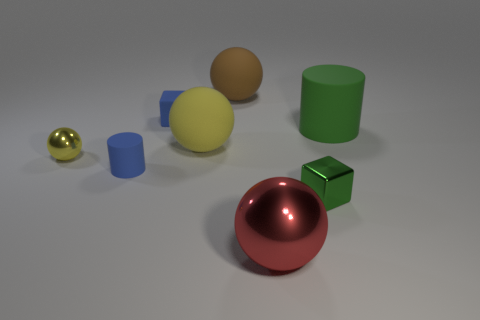If these objects were part of a game, what kind of game could it be? These objects could be part of a puzzle or sorting game where the objective is to group them by shape, color, or size, possibly testing spatial reasoning skills. 